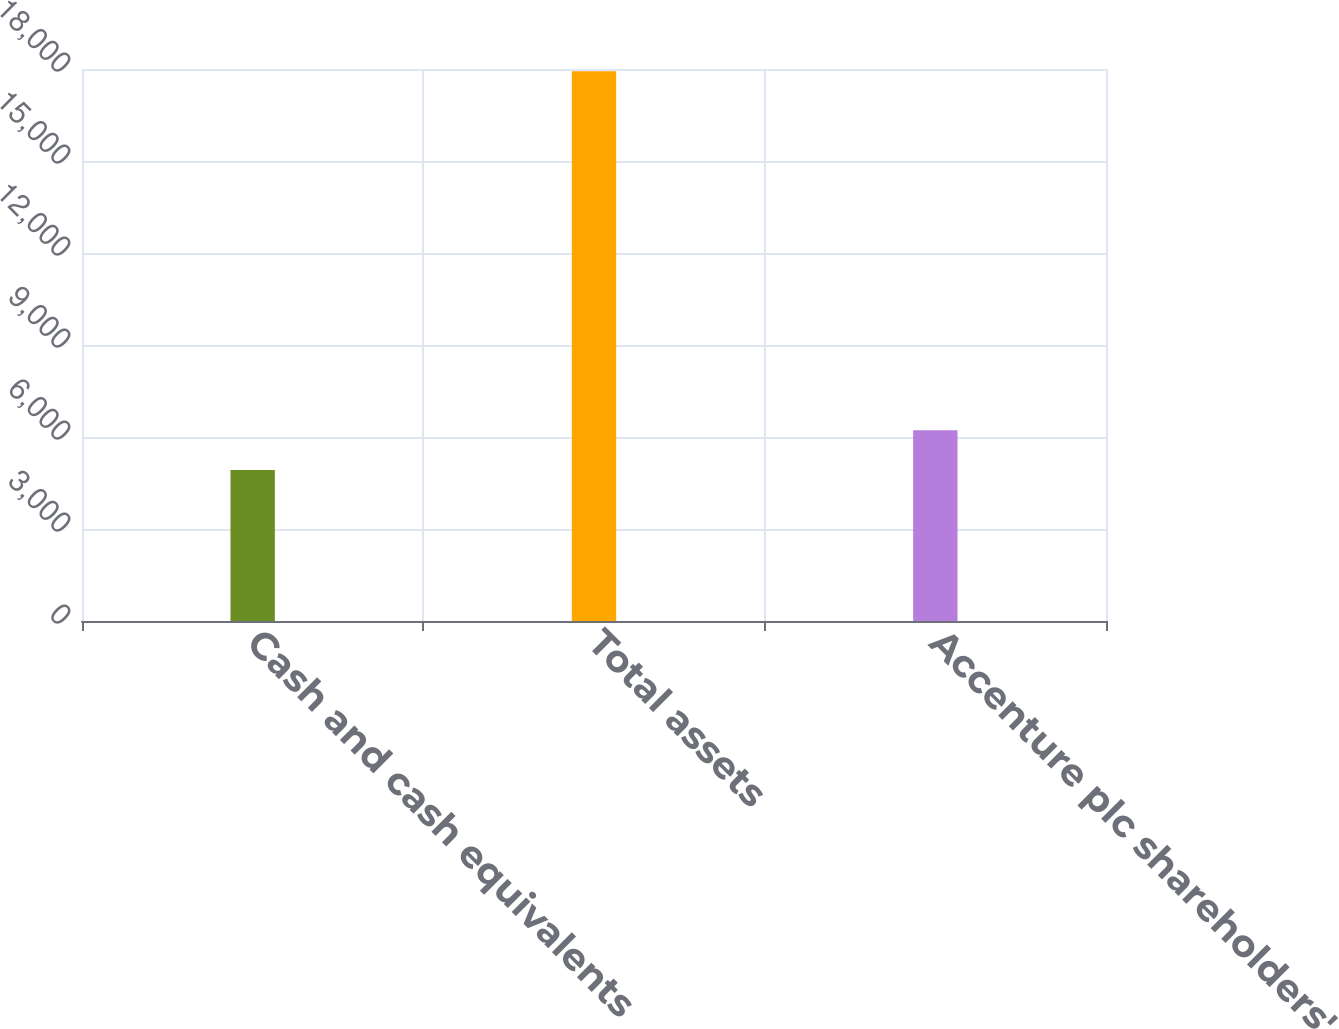Convert chart. <chart><loc_0><loc_0><loc_500><loc_500><bar_chart><fcel>Cash and cash equivalents<fcel>Total assets<fcel>Accenture plc shareholders'<nl><fcel>4921<fcel>17930<fcel>6221.9<nl></chart> 